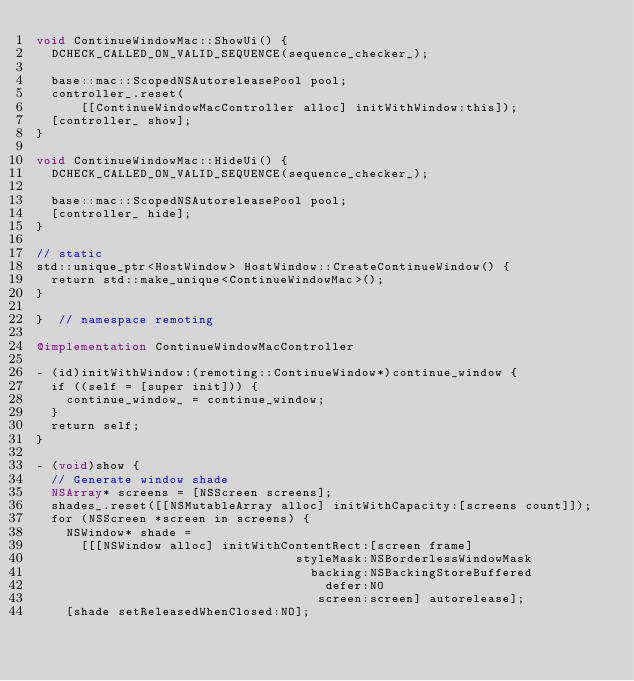Convert code to text. <code><loc_0><loc_0><loc_500><loc_500><_ObjectiveC_>void ContinueWindowMac::ShowUi() {
  DCHECK_CALLED_ON_VALID_SEQUENCE(sequence_checker_);

  base::mac::ScopedNSAutoreleasePool pool;
  controller_.reset(
      [[ContinueWindowMacController alloc] initWithWindow:this]);
  [controller_ show];
}

void ContinueWindowMac::HideUi() {
  DCHECK_CALLED_ON_VALID_SEQUENCE(sequence_checker_);

  base::mac::ScopedNSAutoreleasePool pool;
  [controller_ hide];
}

// static
std::unique_ptr<HostWindow> HostWindow::CreateContinueWindow() {
  return std::make_unique<ContinueWindowMac>();
}

}  // namespace remoting

@implementation ContinueWindowMacController

- (id)initWithWindow:(remoting::ContinueWindow*)continue_window {
  if ((self = [super init])) {
    continue_window_ = continue_window;
  }
  return self;
}

- (void)show {
  // Generate window shade
  NSArray* screens = [NSScreen screens];
  shades_.reset([[NSMutableArray alloc] initWithCapacity:[screens count]]);
  for (NSScreen *screen in screens) {
    NSWindow* shade =
      [[[NSWindow alloc] initWithContentRect:[screen frame]
                                   styleMask:NSBorderlessWindowMask
                                     backing:NSBackingStoreBuffered
                                       defer:NO
                                      screen:screen] autorelease];
    [shade setReleasedWhenClosed:NO];</code> 